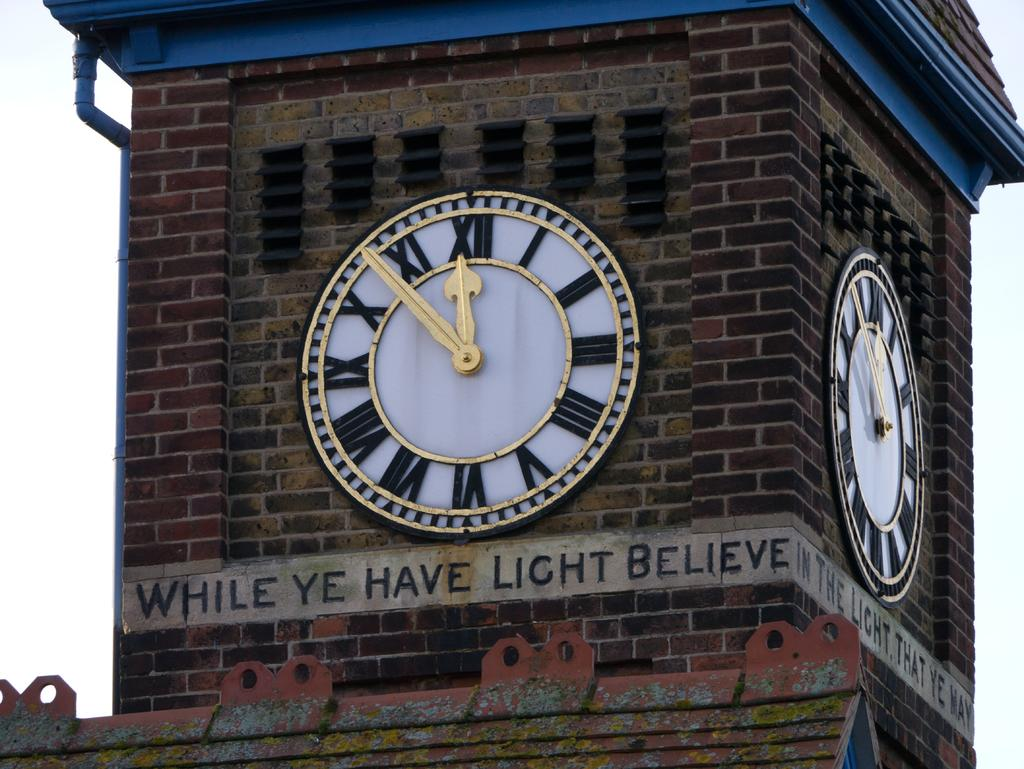<image>
Offer a succinct explanation of the picture presented. Clock on a building with the saying "While ye have light believe" under it. 